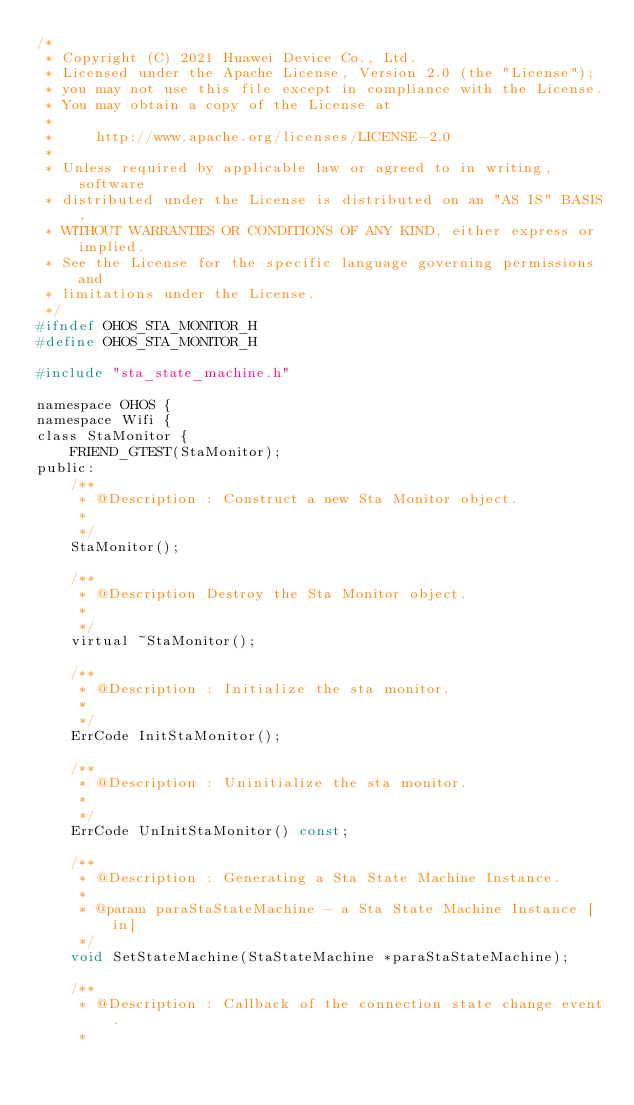<code> <loc_0><loc_0><loc_500><loc_500><_C_>/*
 * Copyright (C) 2021 Huawei Device Co., Ltd.
 * Licensed under the Apache License, Version 2.0 (the "License");
 * you may not use this file except in compliance with the License.
 * You may obtain a copy of the License at
 *
 *     http://www.apache.org/licenses/LICENSE-2.0
 *
 * Unless required by applicable law or agreed to in writing, software
 * distributed under the License is distributed on an "AS IS" BASIS,
 * WITHOUT WARRANTIES OR CONDITIONS OF ANY KIND, either express or implied.
 * See the License for the specific language governing permissions and
 * limitations under the License.
 */
#ifndef OHOS_STA_MONITOR_H
#define OHOS_STA_MONITOR_H

#include "sta_state_machine.h"

namespace OHOS {
namespace Wifi {
class StaMonitor {
    FRIEND_GTEST(StaMonitor);
public:
    /**
     * @Description : Construct a new Sta Monitor object.
     *
     */
    StaMonitor();

    /**
     * @Description Destroy the Sta Monitor object.
     *
     */
    virtual ~StaMonitor();

    /**
     * @Description : Initialize the sta monitor.
     *
     */
    ErrCode InitStaMonitor();

    /**
     * @Description : Uninitialize the sta monitor.
     *
     */
    ErrCode UnInitStaMonitor() const;

    /**
     * @Description : Generating a Sta State Machine Instance.
     *
     * @param paraStaStateMachine - a Sta State Machine Instance [in]
     */
    void SetStateMachine(StaStateMachine *paraStaStateMachine);

    /**
     * @Description : Callback of the connection state change event.
     *</code> 